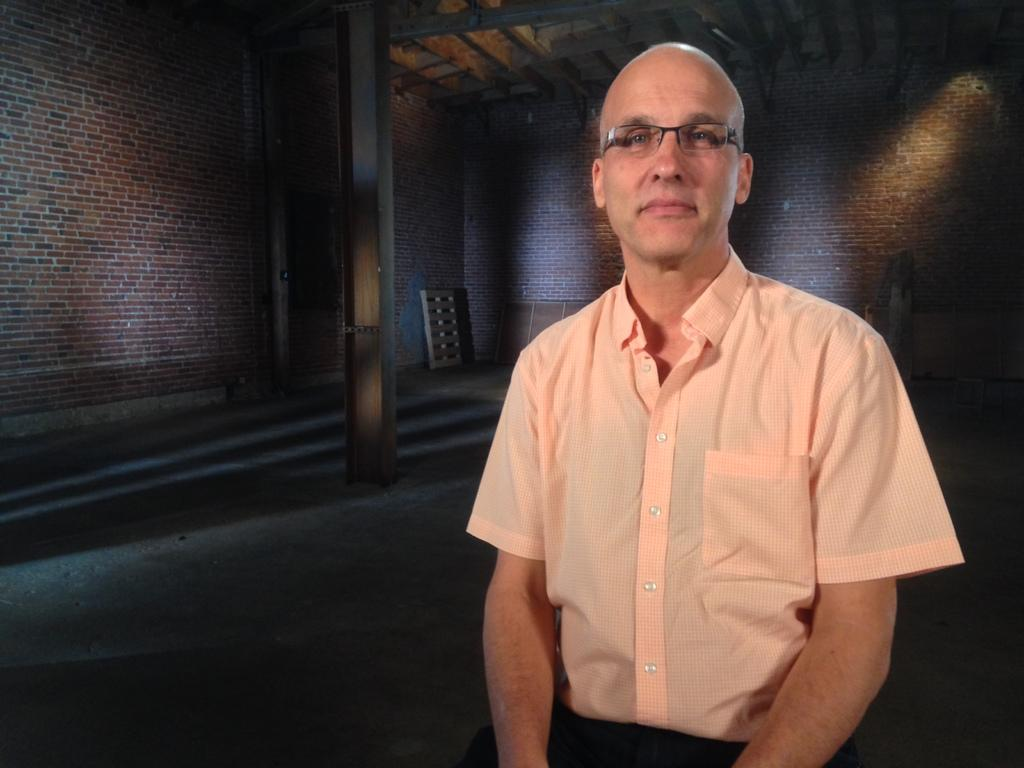What is the person in the image doing? The person is sitting in the image. Can you describe the person's appearance? The person is wearing spectacles. What can be seen in the background of the image? There are walls, at least one pillar, and other objects in the background of the image. What type of prose is the person reading in the image? There is no indication in the image that the person is reading any prose, as the image does not show any books or written material. 